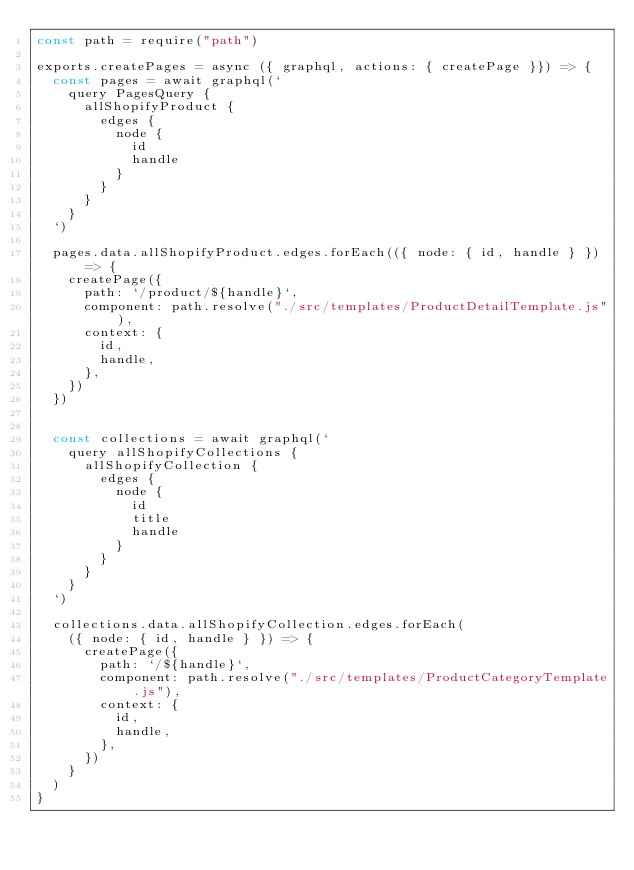<code> <loc_0><loc_0><loc_500><loc_500><_JavaScript_>const path = require("path")

exports.createPages = async ({ graphql, actions: { createPage }}) => {
  const pages = await graphql(`
    query PagesQuery {
      allShopifyProduct {
        edges {
          node {
            id
            handle
          }
        }
      }
    }
  `)

  pages.data.allShopifyProduct.edges.forEach(({ node: { id, handle } }) => {
    createPage({
      path: `/product/${handle}`,
      component: path.resolve("./src/templates/ProductDetailTemplate.js"),
      context: {
        id,
        handle,
      },
    })
  })


  const collections = await graphql(`
    query allShopifyCollections {
      allShopifyCollection {
        edges {
          node {
            id
            title
            handle
          }
        }
      }
    }
  `)

  collections.data.allShopifyCollection.edges.forEach(
    ({ node: { id, handle } }) => {
      createPage({
        path: `/${handle}`,
        component: path.resolve("./src/templates/ProductCategoryTemplate.js"),
        context: {
          id,
          handle,
        },
      })
    }
  )
}</code> 